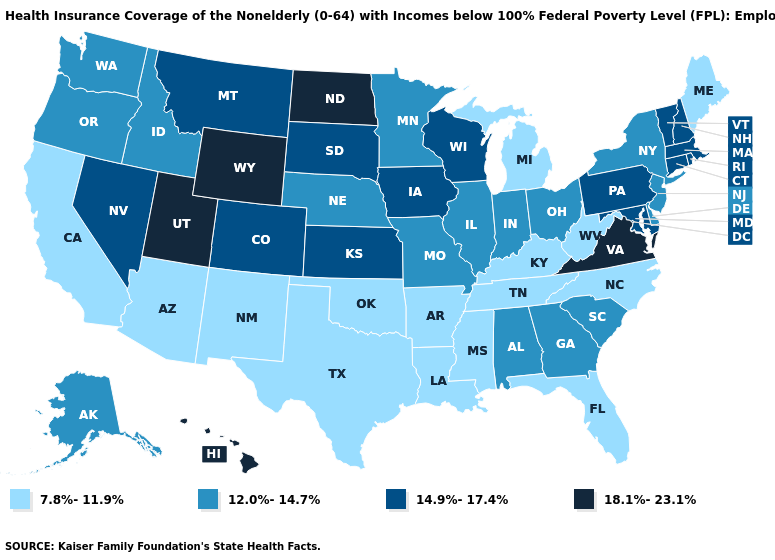Does California have the same value as Oregon?
Answer briefly. No. What is the value of Montana?
Quick response, please. 14.9%-17.4%. Name the states that have a value in the range 7.8%-11.9%?
Answer briefly. Arizona, Arkansas, California, Florida, Kentucky, Louisiana, Maine, Michigan, Mississippi, New Mexico, North Carolina, Oklahoma, Tennessee, Texas, West Virginia. Does South Carolina have the same value as New Hampshire?
Quick response, please. No. What is the value of Illinois?
Short answer required. 12.0%-14.7%. What is the value of New Mexico?
Be succinct. 7.8%-11.9%. What is the value of Oklahoma?
Concise answer only. 7.8%-11.9%. Does Pennsylvania have the lowest value in the USA?
Write a very short answer. No. Does North Dakota have the same value as New Jersey?
Be succinct. No. Does Maine have a lower value than Pennsylvania?
Give a very brief answer. Yes. How many symbols are there in the legend?
Short answer required. 4. Does the map have missing data?
Be succinct. No. Does Texas have the highest value in the USA?
Keep it brief. No. 